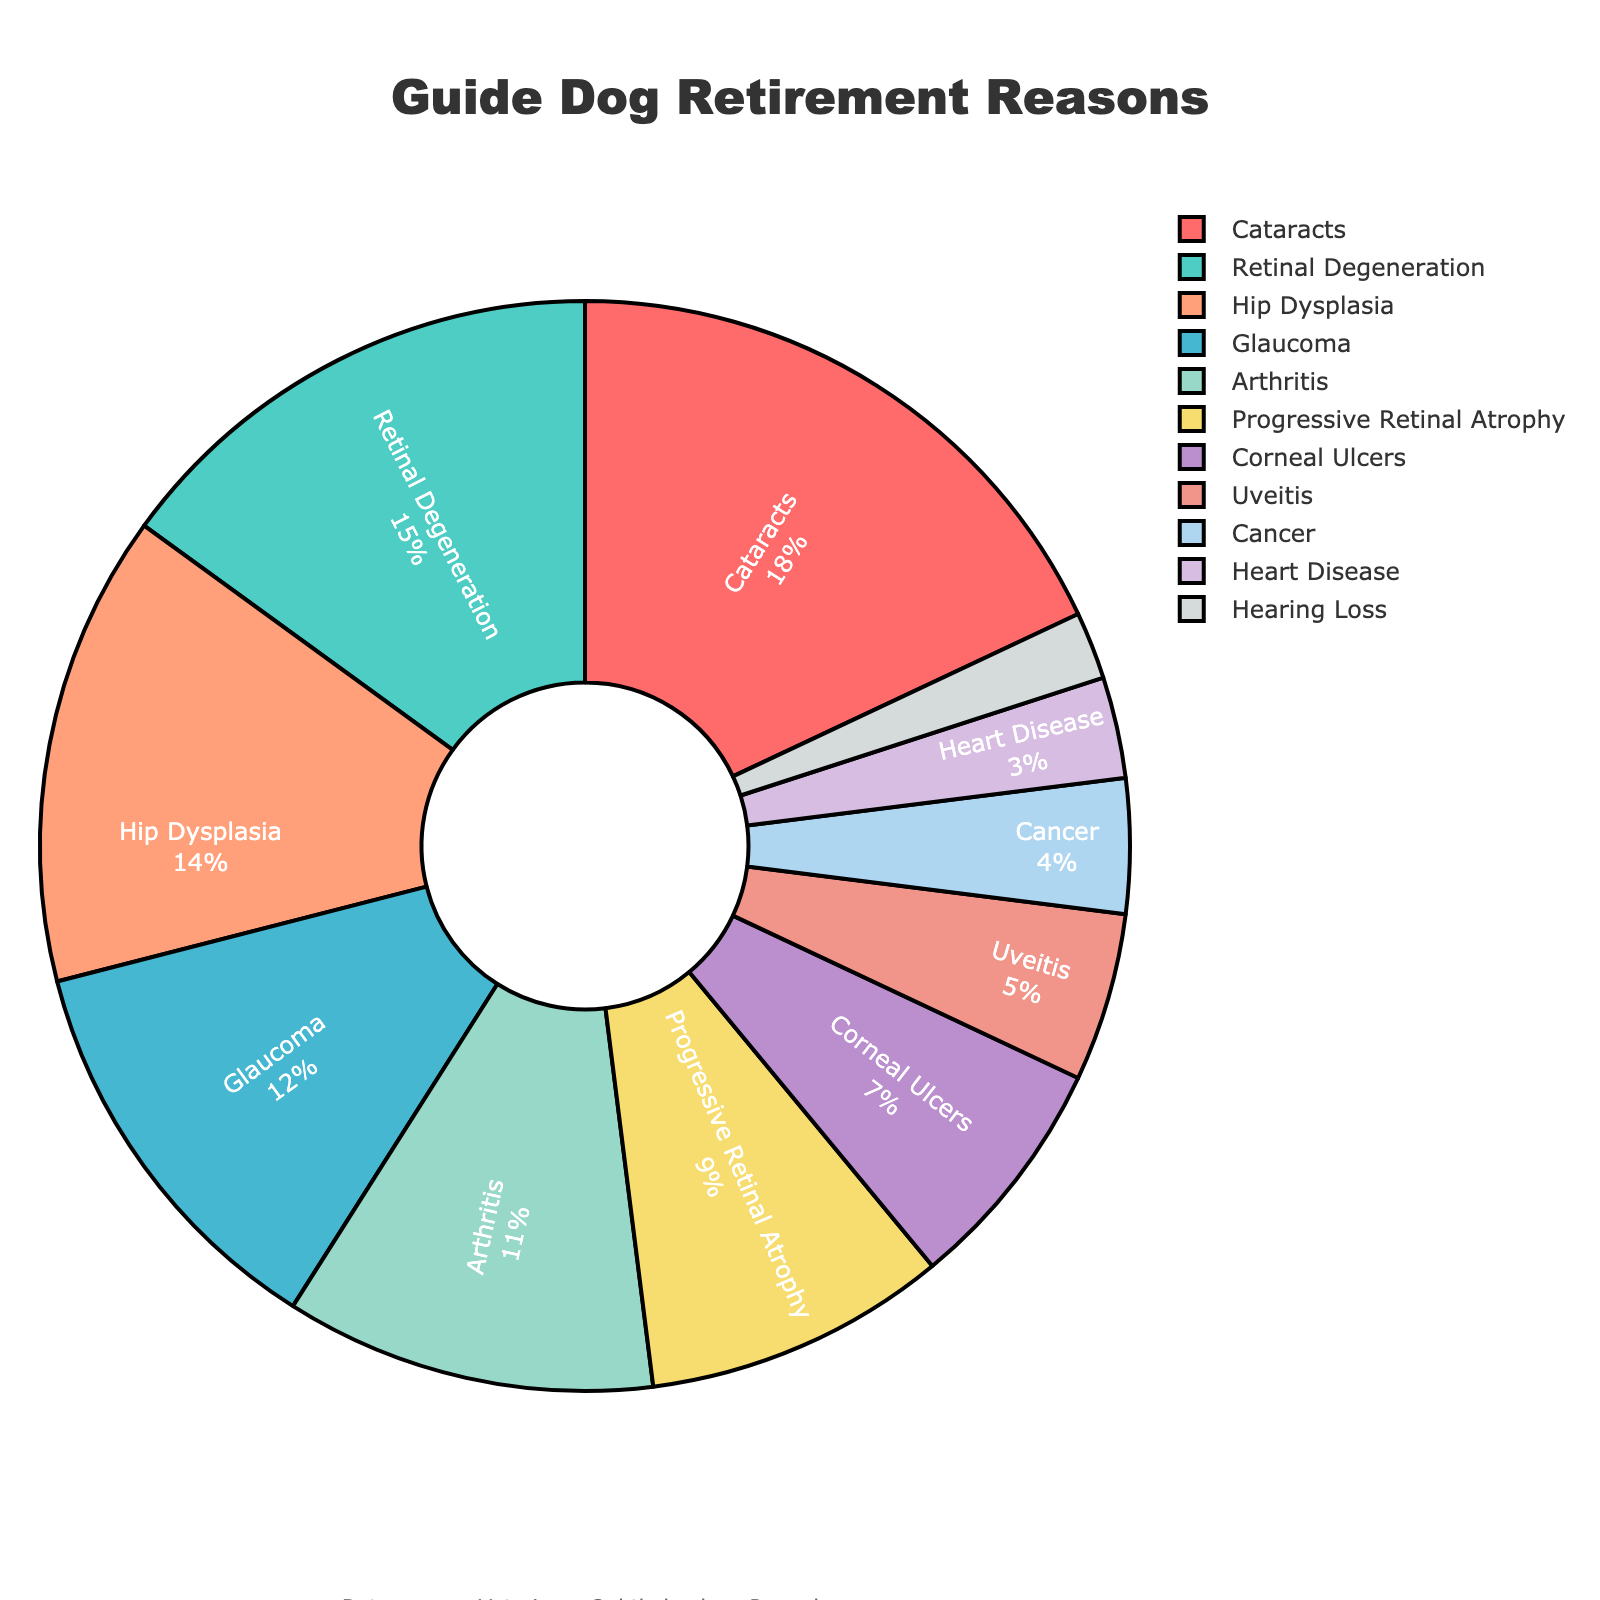What health reason has the highest proportion of guide dog retirements? Looking at the pie chart, the largest segment corresponds to Cataracts. The label shows Cataracts have 18%. Thus, Cataracts is the health reason with the highest proportion of retirements.
Answer: Cataracts Which two health reasons have the smallest proportions of guide dog retirements? Observing the pie chart, the smallest segments are for Hearing Loss and Heart Disease. The labels show 2% and 3% respectively, indicating they have the smallest proportions.
Answer: Hearing Loss and Heart Disease What is the combined percentage of guide dog retirements caused by Glaucoma, Arthritis, and Cancer? From the pie chart, Glaucoma is 12%, Arthritis is 11%, and Cancer is 4%. Adding these together: 12 + 11 + 4 = 27%.
Answer: 27% How does the proportion of guide dog retirements due to Hip Dysplasia compare to those due to Retinal Degeneration? According to the pie chart, the proportion for Hip Dysplasia is 14% and for Retinal Degeneration is 15%. Hip Dysplasia is slightly less than Retinal Degeneration.
Answer: Less than Which segment is represented by a reddish color? Noticing the color code, the reddish segment corresponds to Cataracts. The label confirms Cataracts make up 18% of the retirements.
Answer: Cataracts What is the difference in the proportion of guide dog retirements due to Cataracts and Progressive Retinal Atrophy? The pie chart shows Cataracts at 18% and Progressive Retinal Atrophy at 9%. The difference is calculated as 18 - 9 = 9%.
Answer: 9% What percentage of retirements are due to vision-related (ophthalmologic) conditions? Sum the percentages for Cataracts (18%), Retinal Degeneration (15%), Glaucoma (12%), Progressive Retinal Atrophy (9%), Corneal Ulcers (7%), and Uveitis (5%). Thus, 18 + 15 + 12 + 9 + 7 + 5 = 66%.
Answer: 66% How are the proportions of guide dog retirements due to Uveitis and Heart Disease visually represented? The pie chart shows Uveitis in a segment color close to pink at 5%, and Heart Disease in a segment color close to purple at 3%. This indicates Uveitis is represented by a larger segment than Heart Disease.
Answer: Uveitis is larger than Heart Disease 